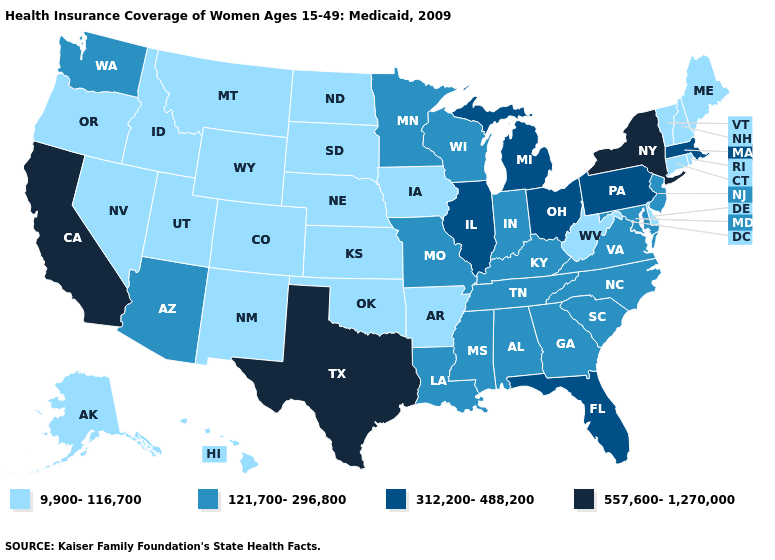What is the lowest value in states that border Kansas?
Write a very short answer. 9,900-116,700. Does North Dakota have the lowest value in the MidWest?
Short answer required. Yes. What is the highest value in the USA?
Answer briefly. 557,600-1,270,000. Name the states that have a value in the range 121,700-296,800?
Answer briefly. Alabama, Arizona, Georgia, Indiana, Kentucky, Louisiana, Maryland, Minnesota, Mississippi, Missouri, New Jersey, North Carolina, South Carolina, Tennessee, Virginia, Washington, Wisconsin. Among the states that border North Dakota , which have the highest value?
Short answer required. Minnesota. Does the map have missing data?
Answer briefly. No. What is the value of Colorado?
Answer briefly. 9,900-116,700. Does the map have missing data?
Concise answer only. No. Does Massachusetts have the lowest value in the USA?
Concise answer only. No. Does Mississippi have the lowest value in the USA?
Write a very short answer. No. Name the states that have a value in the range 312,200-488,200?
Answer briefly. Florida, Illinois, Massachusetts, Michigan, Ohio, Pennsylvania. Name the states that have a value in the range 9,900-116,700?
Concise answer only. Alaska, Arkansas, Colorado, Connecticut, Delaware, Hawaii, Idaho, Iowa, Kansas, Maine, Montana, Nebraska, Nevada, New Hampshire, New Mexico, North Dakota, Oklahoma, Oregon, Rhode Island, South Dakota, Utah, Vermont, West Virginia, Wyoming. Does New Jersey have a higher value than Arizona?
Give a very brief answer. No. Name the states that have a value in the range 557,600-1,270,000?
Answer briefly. California, New York, Texas. What is the value of Vermont?
Answer briefly. 9,900-116,700. 